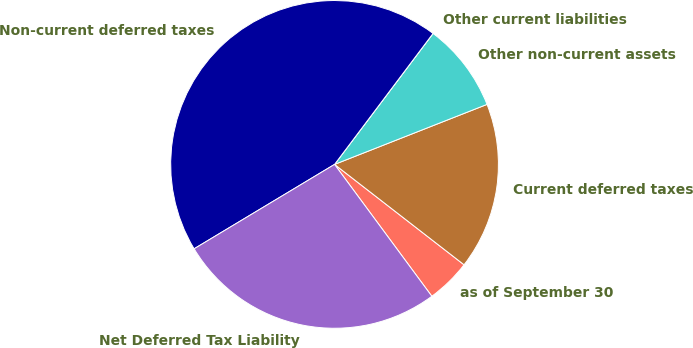<chart> <loc_0><loc_0><loc_500><loc_500><pie_chart><fcel>as of September 30<fcel>Current deferred taxes<fcel>Other non-current assets<fcel>Other current liabilities<fcel>Non-current deferred taxes<fcel>Net Deferred Tax Liability<nl><fcel>4.39%<fcel>16.46%<fcel>8.77%<fcel>0.0%<fcel>43.87%<fcel>26.5%<nl></chart> 